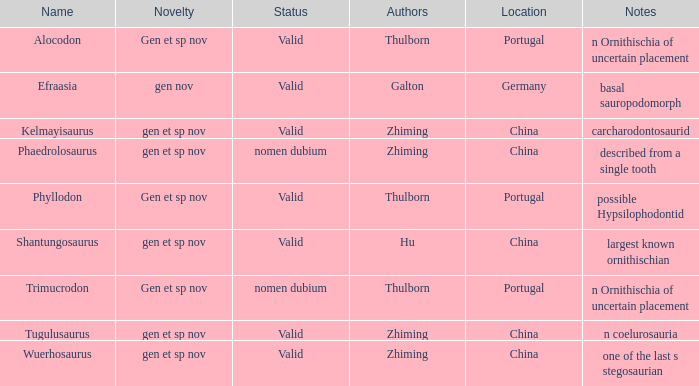What is the uniqueness of the dinosaur, whose naming author was galton? Gen nov. 